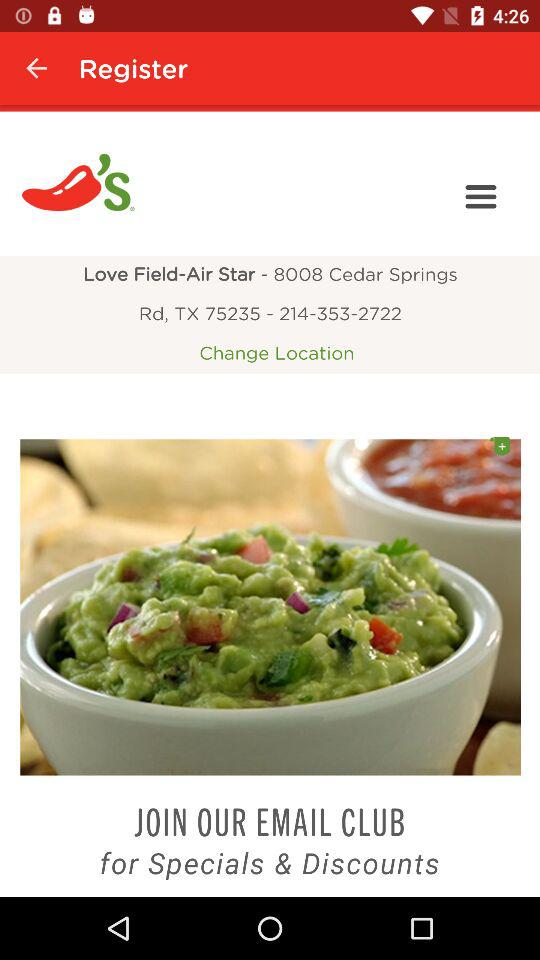What is the contact number?
When the provided information is insufficient, respond with <no answer>. <no answer> 